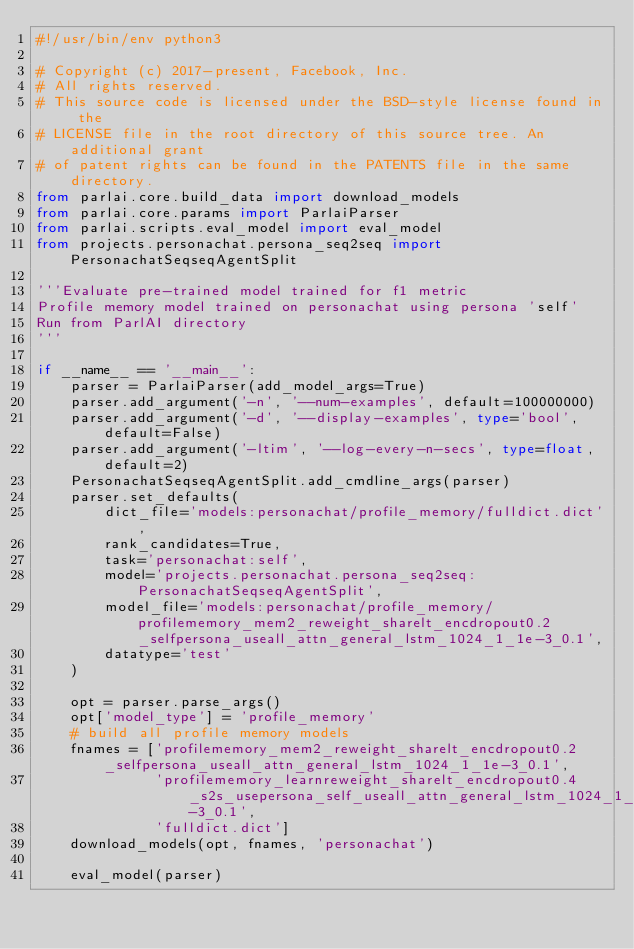Convert code to text. <code><loc_0><loc_0><loc_500><loc_500><_Python_>#!/usr/bin/env python3

# Copyright (c) 2017-present, Facebook, Inc.
# All rights reserved.
# This source code is licensed under the BSD-style license found in the
# LICENSE file in the root directory of this source tree. An additional grant
# of patent rights can be found in the PATENTS file in the same directory.
from parlai.core.build_data import download_models
from parlai.core.params import ParlaiParser
from parlai.scripts.eval_model import eval_model
from projects.personachat.persona_seq2seq import PersonachatSeqseqAgentSplit

'''Evaluate pre-trained model trained for f1 metric
Profile memory model trained on personachat using persona 'self'
Run from ParlAI directory
'''

if __name__ == '__main__':
    parser = ParlaiParser(add_model_args=True)
    parser.add_argument('-n', '--num-examples', default=100000000)
    parser.add_argument('-d', '--display-examples', type='bool', default=False)
    parser.add_argument('-ltim', '--log-every-n-secs', type=float, default=2)
    PersonachatSeqseqAgentSplit.add_cmdline_args(parser)
    parser.set_defaults(
        dict_file='models:personachat/profile_memory/fulldict.dict',
        rank_candidates=True,
        task='personachat:self',
        model='projects.personachat.persona_seq2seq:PersonachatSeqseqAgentSplit',
        model_file='models:personachat/profile_memory/profilememory_mem2_reweight_sharelt_encdropout0.2_selfpersona_useall_attn_general_lstm_1024_1_1e-3_0.1',
        datatype='test'
    )

    opt = parser.parse_args()
    opt['model_type'] = 'profile_memory'
    # build all profile memory models
    fnames = ['profilememory_mem2_reweight_sharelt_encdropout0.2_selfpersona_useall_attn_general_lstm_1024_1_1e-3_0.1',
              'profilememory_learnreweight_sharelt_encdropout0.4_s2s_usepersona_self_useall_attn_general_lstm_1024_1_1e-3_0.1',
              'fulldict.dict']
    download_models(opt, fnames, 'personachat')

    eval_model(parser)
</code> 